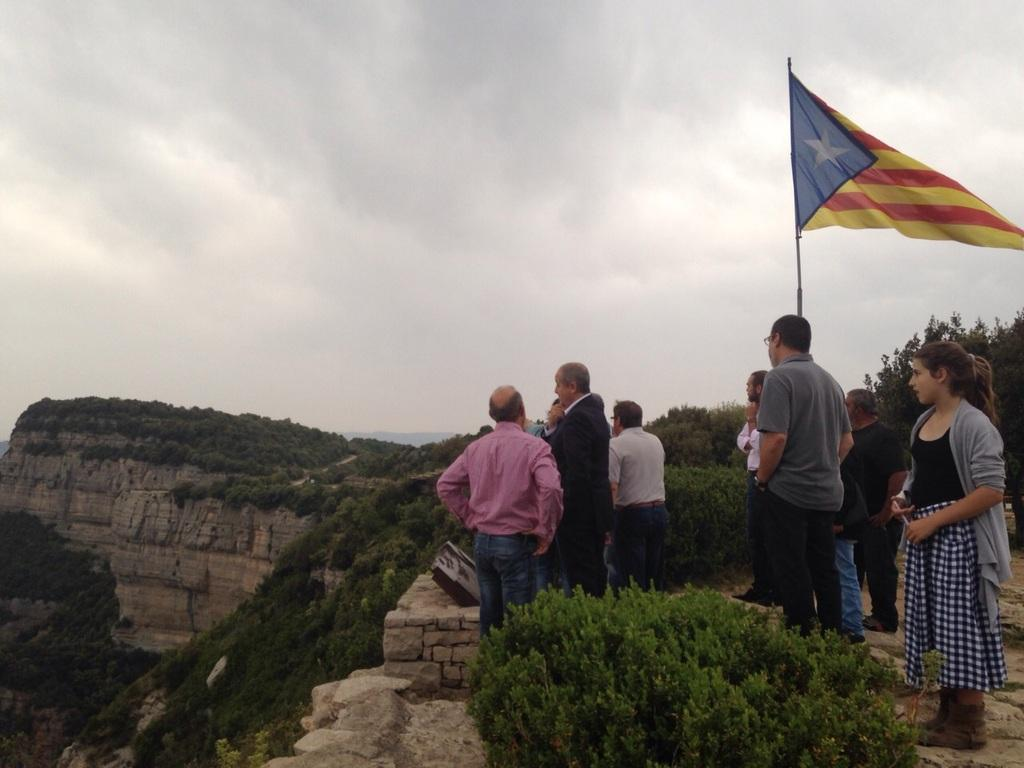What can be seen in the foreground of the image? There are persons standing on the cliff in the foreground of the image, along with greenery. What is visible in the background of the image? There is a flag, greenery, a cliff, and clouds visible in the background of the image. What type of paste is being used by the crowd in the image? There is no crowd or paste present in the image. How many times is the object being smashed in the image? There is no object being smashed in the image. 